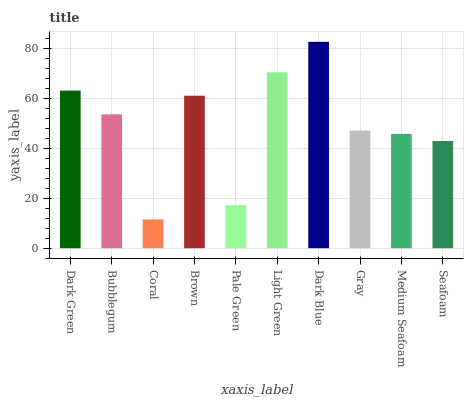Is Coral the minimum?
Answer yes or no. Yes. Is Dark Blue the maximum?
Answer yes or no. Yes. Is Bubblegum the minimum?
Answer yes or no. No. Is Bubblegum the maximum?
Answer yes or no. No. Is Dark Green greater than Bubblegum?
Answer yes or no. Yes. Is Bubblegum less than Dark Green?
Answer yes or no. Yes. Is Bubblegum greater than Dark Green?
Answer yes or no. No. Is Dark Green less than Bubblegum?
Answer yes or no. No. Is Bubblegum the high median?
Answer yes or no. Yes. Is Gray the low median?
Answer yes or no. Yes. Is Gray the high median?
Answer yes or no. No. Is Pale Green the low median?
Answer yes or no. No. 